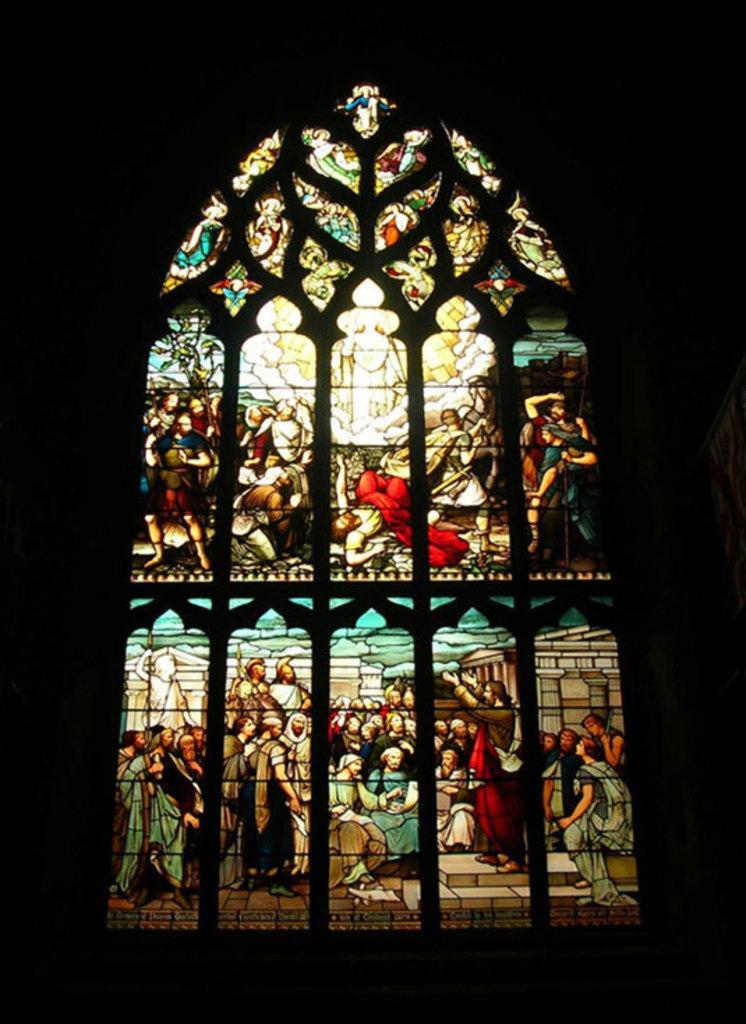Please provide a concise description of this image. This picture seems to be clicked inside. In the center we can see the pictures of some persons standing and we can see the pictures of some objects and the persons on the window of a building. The background of the image is very dark. 